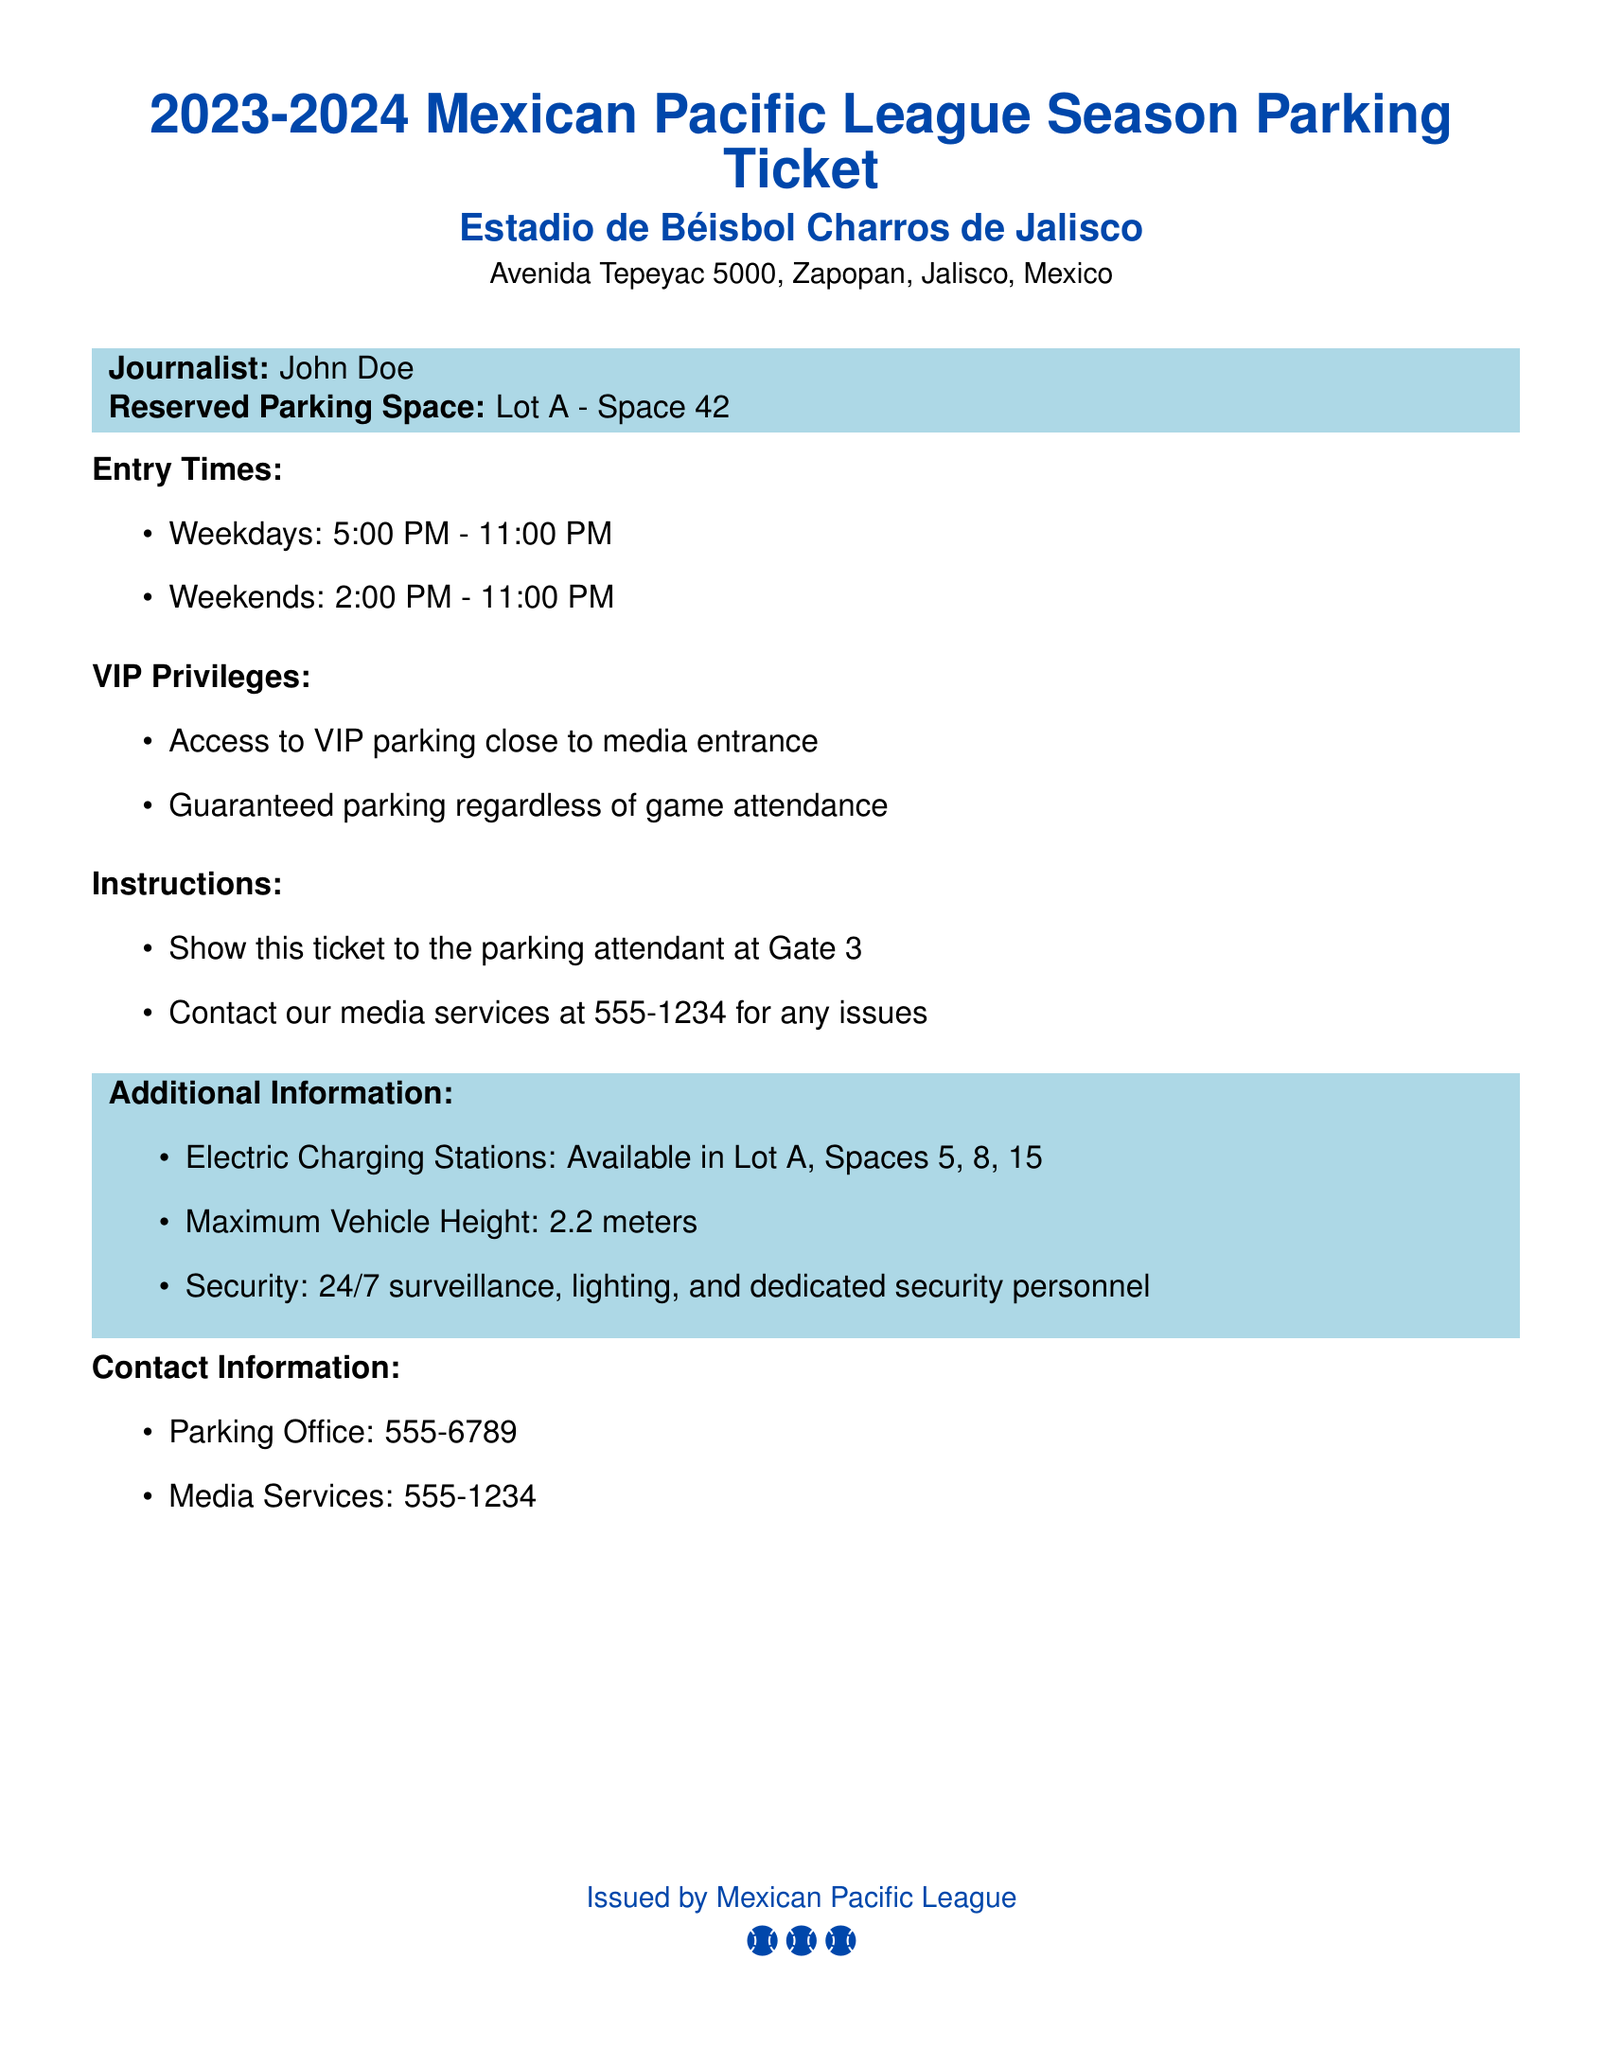What is the reserved parking space? The reserved parking space information is listed in the document, stating "Lot A - Space 42."
Answer: Lot A - Space 42 What are the entry times on weekends? The document specifies entry times for weekends as "2:00 PM - 11:00 PM."
Answer: 2:00 PM - 11:00 PM What is the contact number for media services? The document includes a specific contact number for media services, which is "555-1234."
Answer: 555-1234 What is the maximum vehicle height allowed? The document mentions the maximum vehicle height as "2.2 meters."
Answer: 2.2 meters What privilege is granted regarding game attendance? The document states that there is a privilege of "Guaranteed parking regardless of game attendance."
Answer: Guaranteed parking regardless of game attendance When does VIP parking provide access? The document states that VIP parking provides access "close to media entrance."
Answer: Close to media entrance What is the purpose of showing the ticket? The document instructs to show the ticket to the "parking attendant at Gate 3."
Answer: Parking attendant at Gate 3 How many electric charging stations are available in Lot A? The document lists electric charging stations available in Lot A as located at "Spaces 5, 8, 15," which totals three.
Answer: Three What type of surveillance is provided? The document describes the type of surveillance as "24/7 surveillance, lighting, and dedicated security personnel."
Answer: 24/7 surveillance, lighting, and dedicated security personnel 